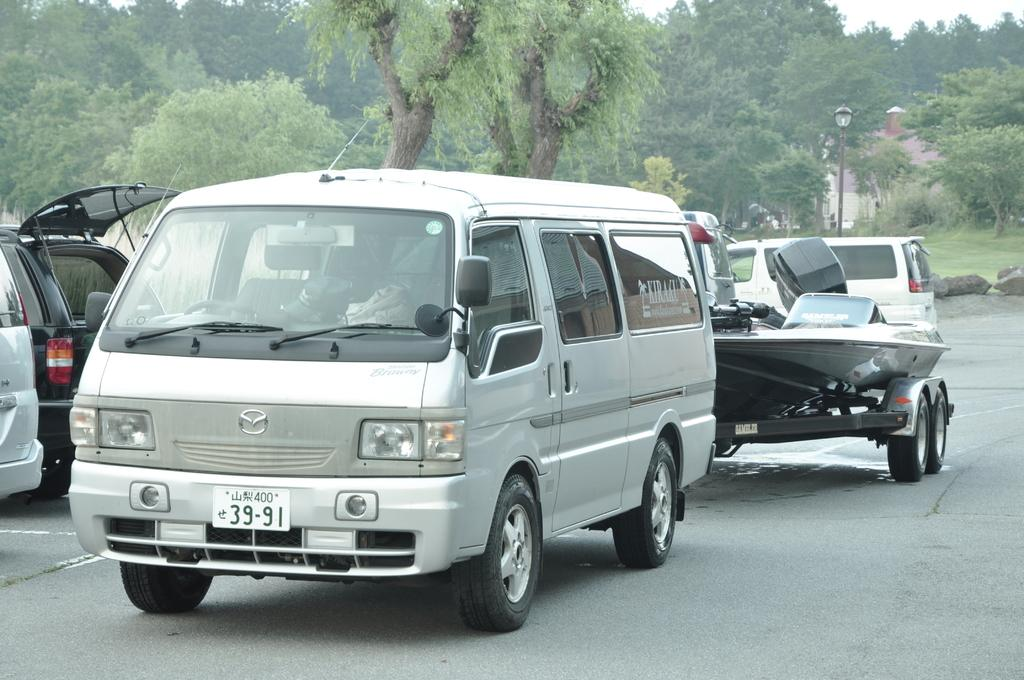<image>
Present a compact description of the photo's key features. A white van with a plate number 39-19, tows a boat behind it. 